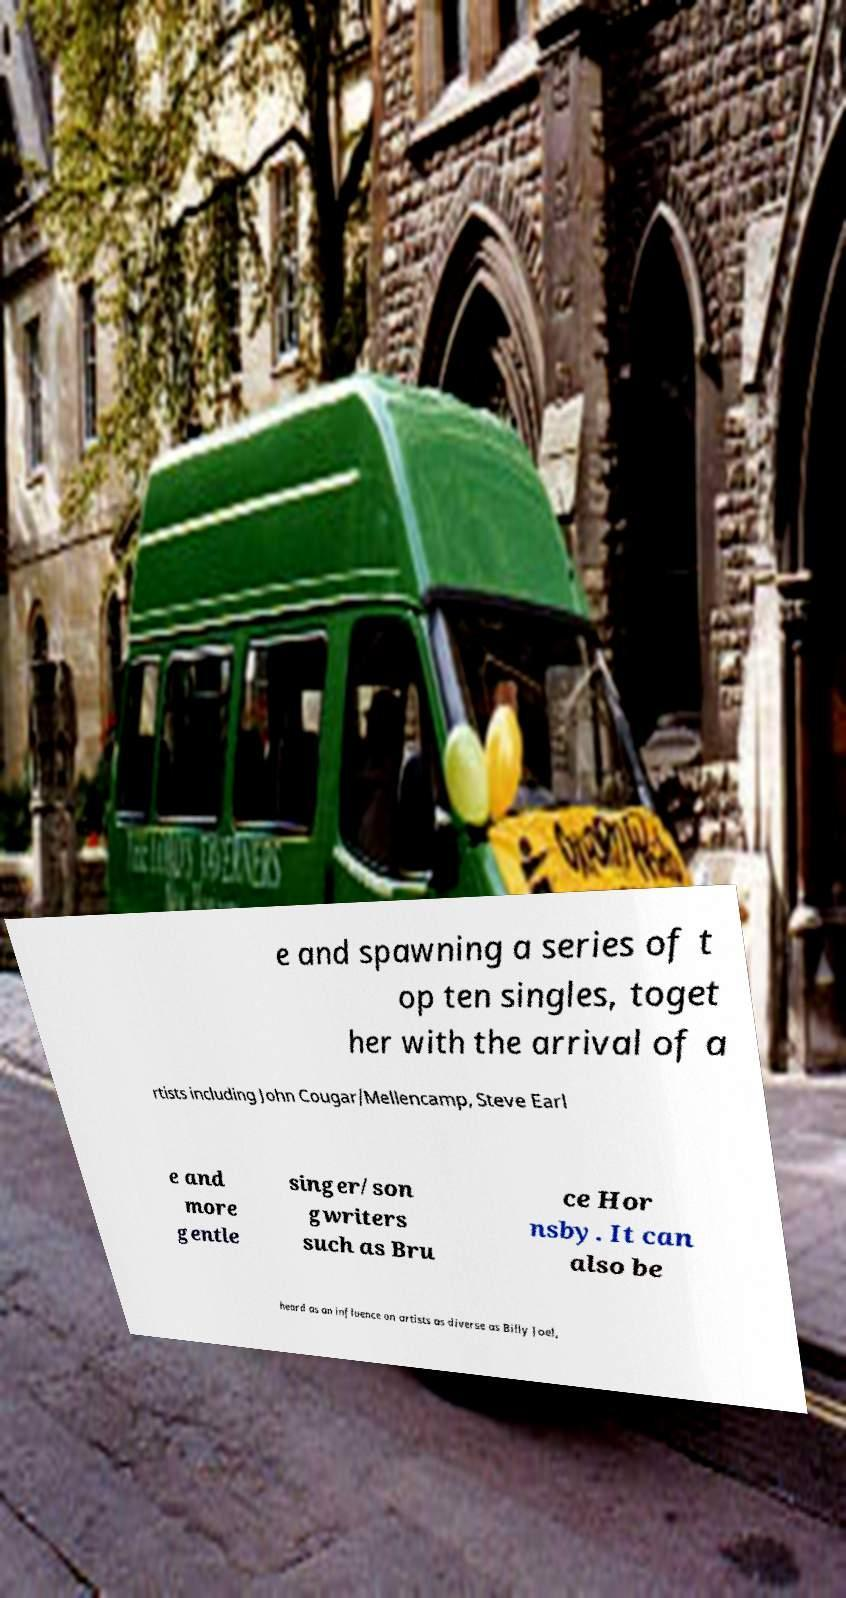Please identify and transcribe the text found in this image. e and spawning a series of t op ten singles, toget her with the arrival of a rtists including John Cougar/Mellencamp, Steve Earl e and more gentle singer/son gwriters such as Bru ce Hor nsby. It can also be heard as an influence on artists as diverse as Billy Joel, 